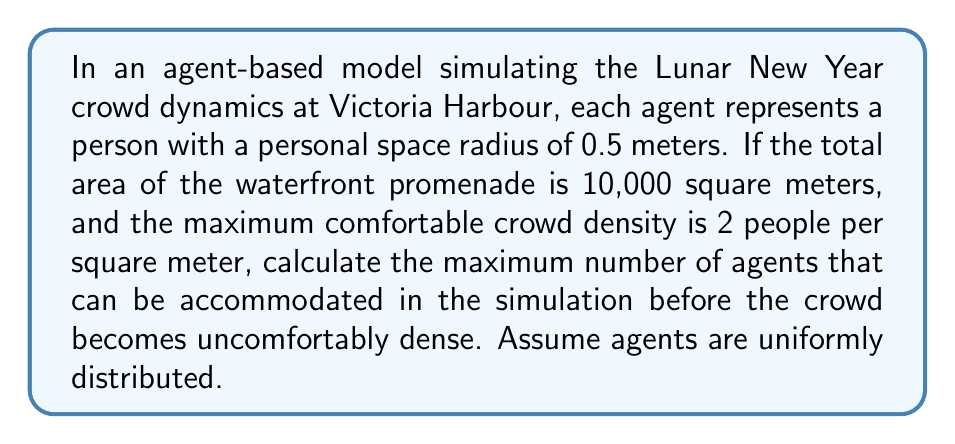Can you solve this math problem? To solve this problem, we'll follow these steps:

1. Calculate the area occupied by each agent:
   The personal space of each agent is a circle with radius 0.5 meters.
   Area per agent = $\pi r^2 = \pi (0.5)^2 = 0.25\pi$ square meters

2. Calculate the maximum number of agents based on the given density:
   Maximum comfortable density = 2 people per square meter
   Total area = 10,000 square meters
   Maximum number of agents = $10,000 \times 2 = 20,000$ agents

3. Calculate the area occupied by 20,000 agents:
   Total occupied area = $20,000 \times 0.25\pi = 5000\pi$ square meters

4. Compare the occupied area with the total area:
   $5000\pi \approx 15,708$ square meters, which is greater than 10,000 square meters

5. Adjust the number of agents to fit within 10,000 square meters:
   Let $x$ be the number of agents
   $0.25\pi x = 10,000$
   $x = 10,000 / (0.25\pi) \approx 12,732$ agents

Therefore, the maximum number of agents that can be accommodated in the simulation before the crowd becomes uncomfortably dense is approximately 12,732.
Answer: 12,732 agents 